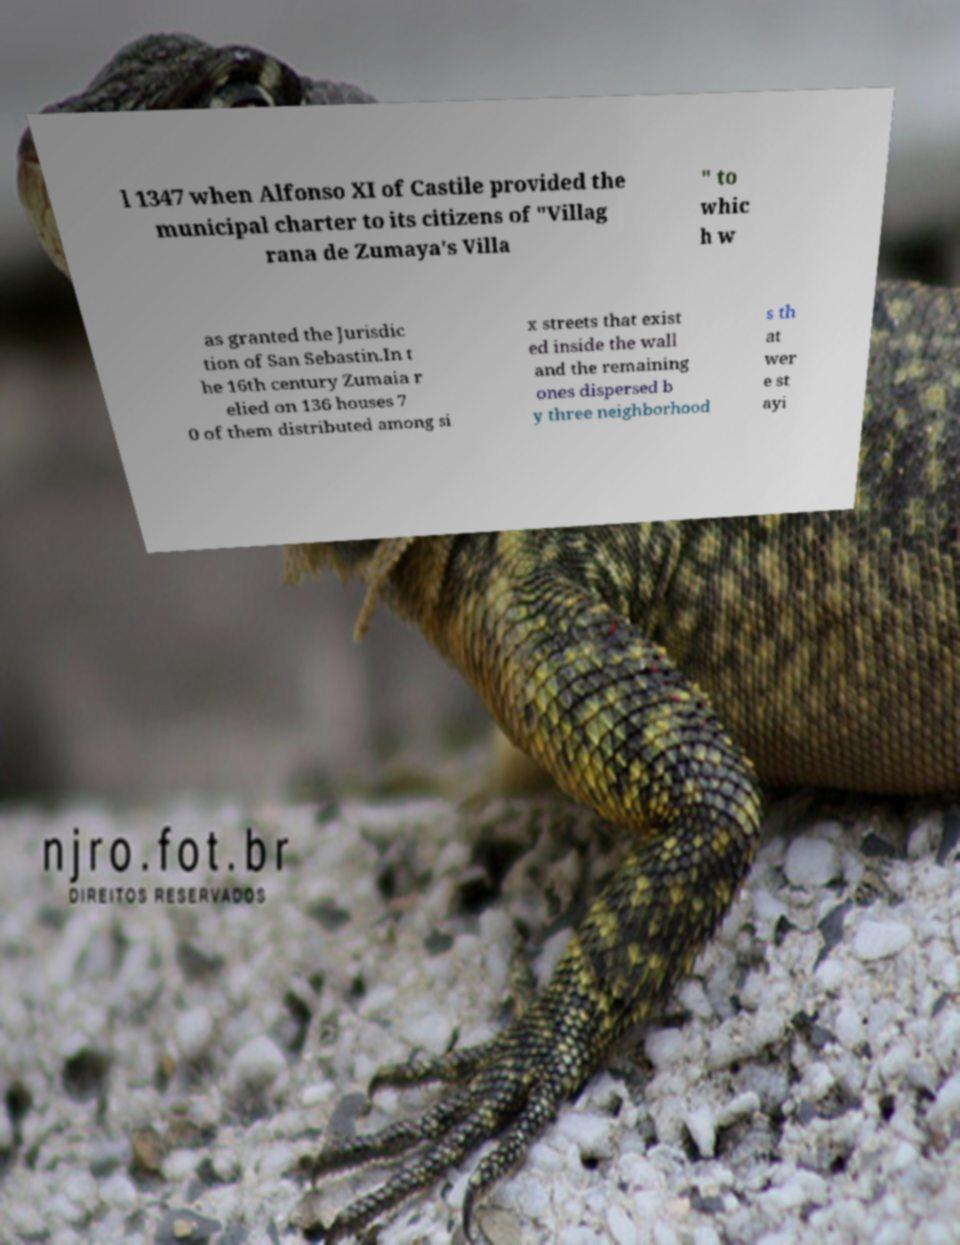Can you read and provide the text displayed in the image?This photo seems to have some interesting text. Can you extract and type it out for me? l 1347 when Alfonso XI of Castile provided the municipal charter to its citizens of "Villag rana de Zumaya's Villa " to whic h w as granted the Jurisdic tion of San Sebastin.In t he 16th century Zumaia r elied on 136 houses 7 0 of them distributed among si x streets that exist ed inside the wall and the remaining ones dispersed b y three neighborhood s th at wer e st ayi 